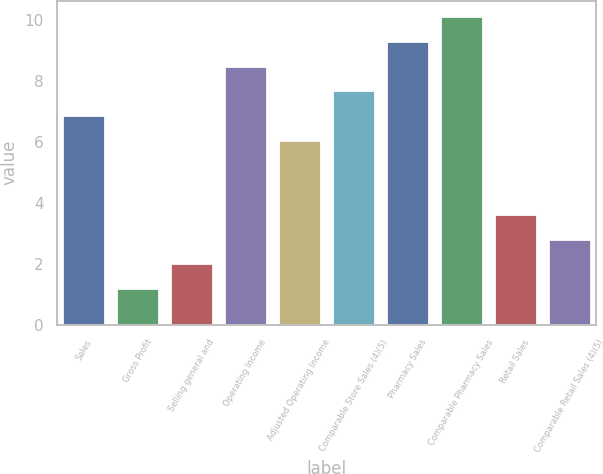Convert chart. <chart><loc_0><loc_0><loc_500><loc_500><bar_chart><fcel>Sales<fcel>Gross Profit<fcel>Selling general and<fcel>Operating Income<fcel>Adjusted Operating Income<fcel>Comparable Store Sales (4)(5)<fcel>Pharmacy Sales<fcel>Comparable Pharmacy Sales<fcel>Retail Sales<fcel>Comparable Retail Sales (4)(5)<nl><fcel>6.87<fcel>1.2<fcel>2.01<fcel>8.49<fcel>6.06<fcel>7.68<fcel>9.3<fcel>10.11<fcel>3.63<fcel>2.82<nl></chart> 